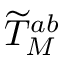<formula> <loc_0><loc_0><loc_500><loc_500>{ \widetilde { T } } _ { M } ^ { a b }</formula> 